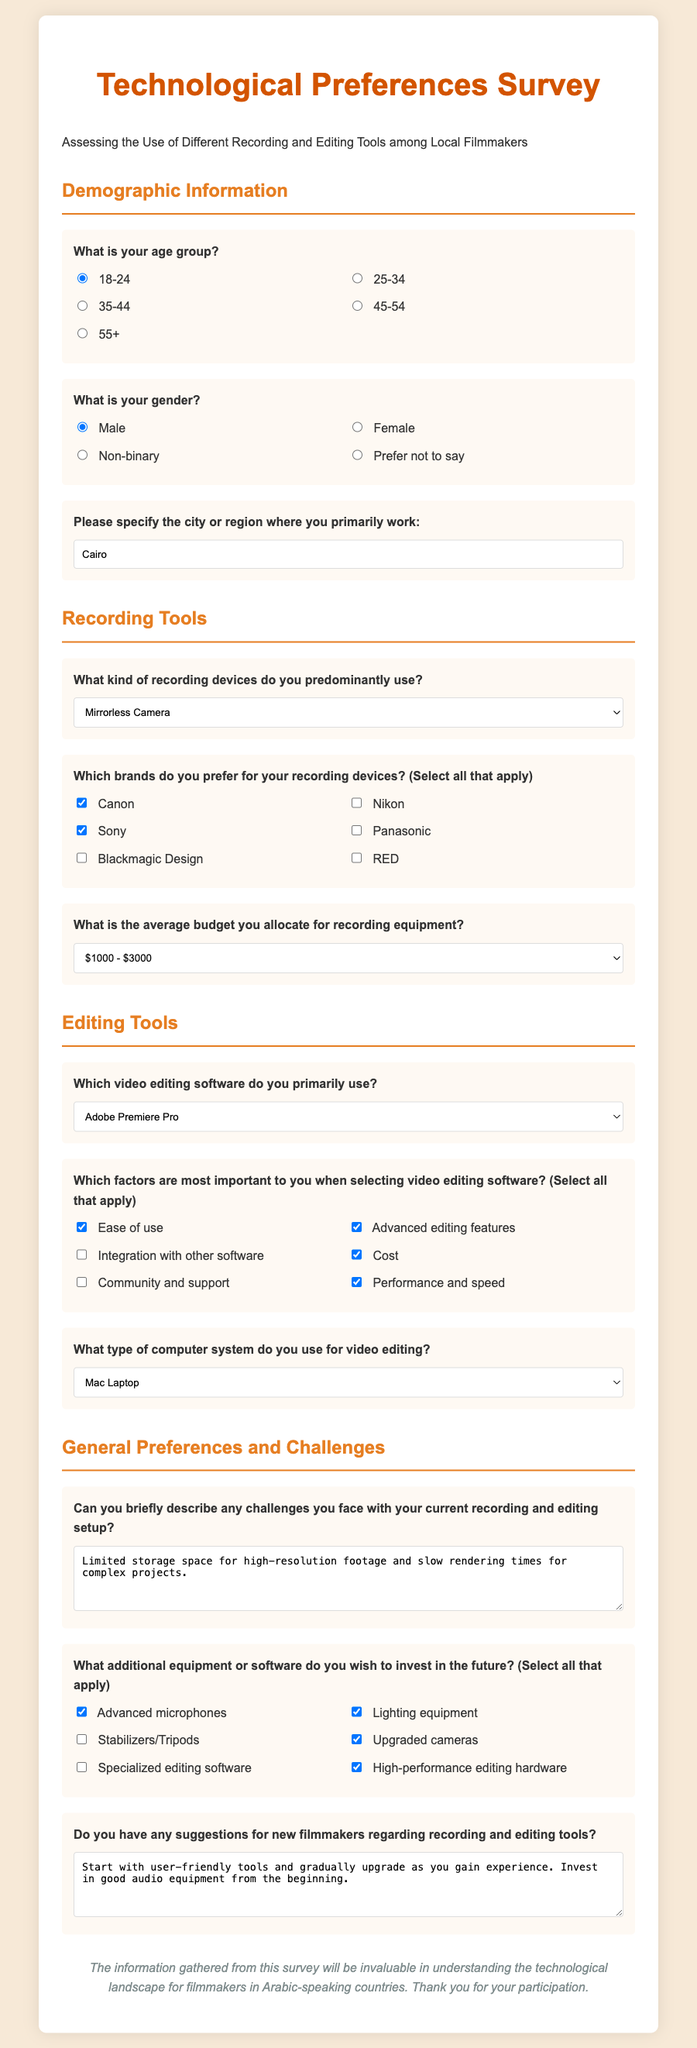What is the title of the survey? The title of the survey is displayed prominently at the top of the document.
Answer: Technological Preferences Survey What age group is the default selected option? The default option selected in the age group question indicates the most common or preferred choice.
Answer: 18-24 Which recording device is selected as the predominant choice? The survey provides a dropdown menu where one option is pre-selected, indicating the preferred type of device.
Answer: Mirrorless Camera What software is primarily used for video editing? The dropdown menu lists options for video editing software, with one being pre-selected.
Answer: Adobe Premiere Pro What is the average budget range selected for recording equipment? The average budget is indicated in a dropdown menu, showing the commonly allocated amount.
Answer: $1000 - $3000 What is the most important factor for selecting video editing software? The survey allows multiple responses for selecting important factors, highlighting user preferences.
Answer: Ease of use What challenges are mentioned regarding recording and editing setup? The text area provides an opportunity for respondents to detail challenges, listing specific issues they face.
Answer: Limited storage space for high-resolution footage and slow rendering times for complex projects Which filming equipment do respondents wish to invest in? The survey identifies various options, with some being checked as desired future investments.
Answer: Advanced microphones What suggestion is made for new filmmakers? The open text area allows respondents to provide advice, reflecting common wisdom or personal insights.
Answer: Start with user-friendly tools and gradually upgrade as you gain experience 